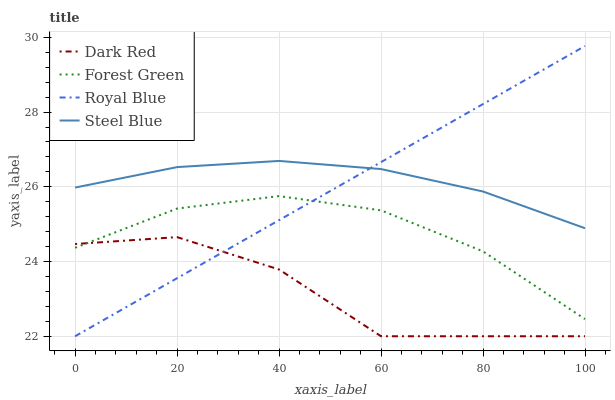Does Dark Red have the minimum area under the curve?
Answer yes or no. Yes. Does Steel Blue have the maximum area under the curve?
Answer yes or no. Yes. Does Forest Green have the minimum area under the curve?
Answer yes or no. No. Does Forest Green have the maximum area under the curve?
Answer yes or no. No. Is Royal Blue the smoothest?
Answer yes or no. Yes. Is Dark Red the roughest?
Answer yes or no. Yes. Is Forest Green the smoothest?
Answer yes or no. No. Is Forest Green the roughest?
Answer yes or no. No. Does Dark Red have the lowest value?
Answer yes or no. Yes. Does Forest Green have the lowest value?
Answer yes or no. No. Does Royal Blue have the highest value?
Answer yes or no. Yes. Does Forest Green have the highest value?
Answer yes or no. No. Is Dark Red less than Steel Blue?
Answer yes or no. Yes. Is Steel Blue greater than Forest Green?
Answer yes or no. Yes. Does Steel Blue intersect Royal Blue?
Answer yes or no. Yes. Is Steel Blue less than Royal Blue?
Answer yes or no. No. Is Steel Blue greater than Royal Blue?
Answer yes or no. No. Does Dark Red intersect Steel Blue?
Answer yes or no. No. 